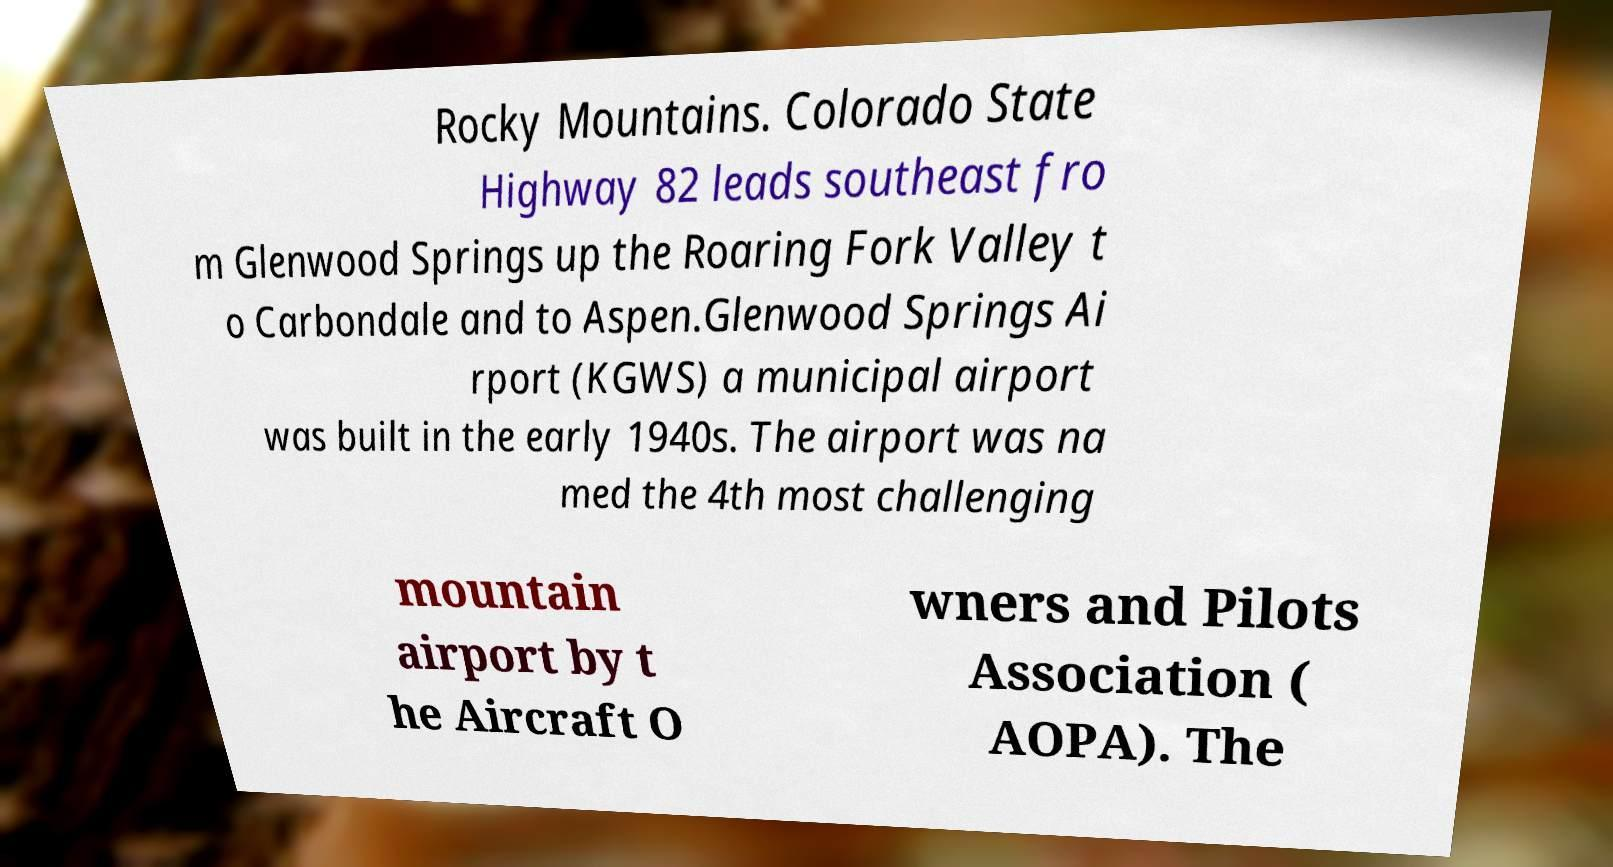Could you assist in decoding the text presented in this image and type it out clearly? Rocky Mountains. Colorado State Highway 82 leads southeast fro m Glenwood Springs up the Roaring Fork Valley t o Carbondale and to Aspen.Glenwood Springs Ai rport (KGWS) a municipal airport was built in the early 1940s. The airport was na med the 4th most challenging mountain airport by t he Aircraft O wners and Pilots Association ( AOPA). The 